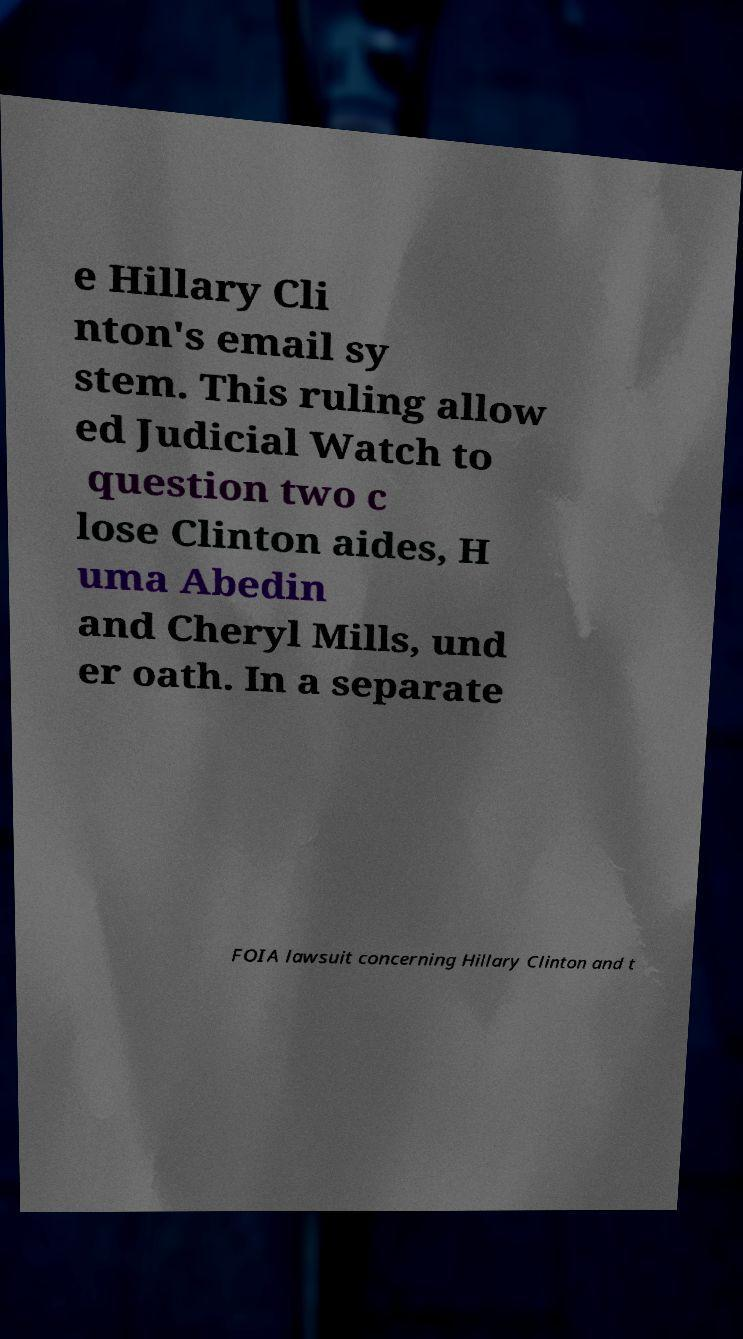I need the written content from this picture converted into text. Can you do that? e Hillary Cli nton's email sy stem. This ruling allow ed Judicial Watch to question two c lose Clinton aides, H uma Abedin and Cheryl Mills, und er oath. In a separate FOIA lawsuit concerning Hillary Clinton and t 